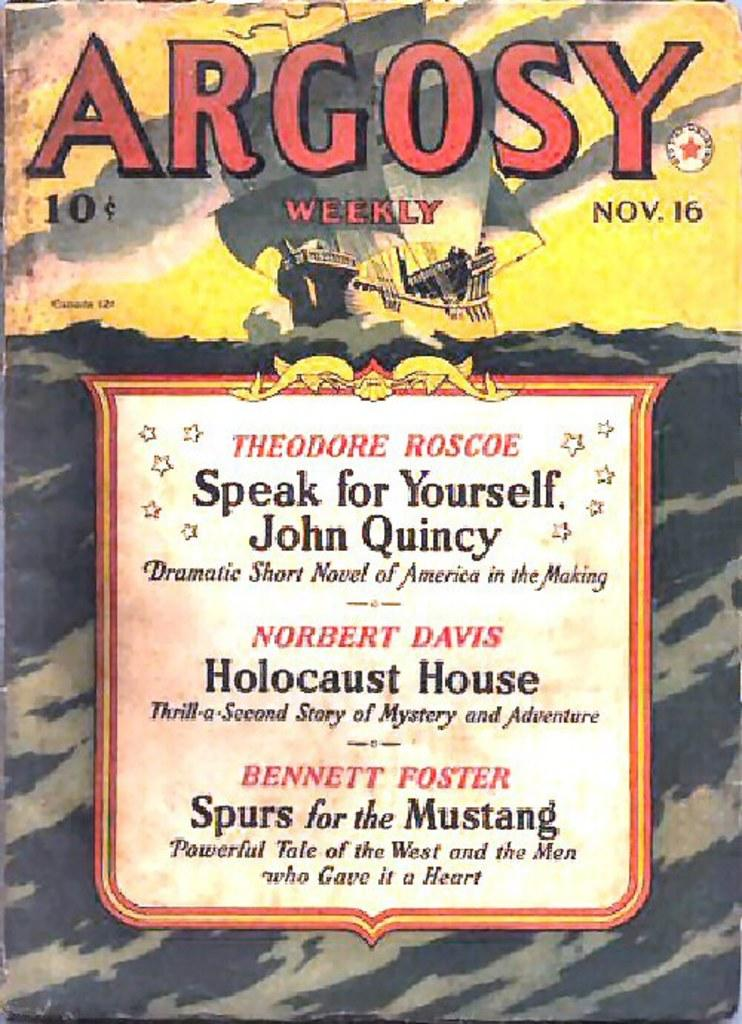Provide a one-sentence caption for the provided image. The cover of Argosy featuring Holocaust House and two other stories. 